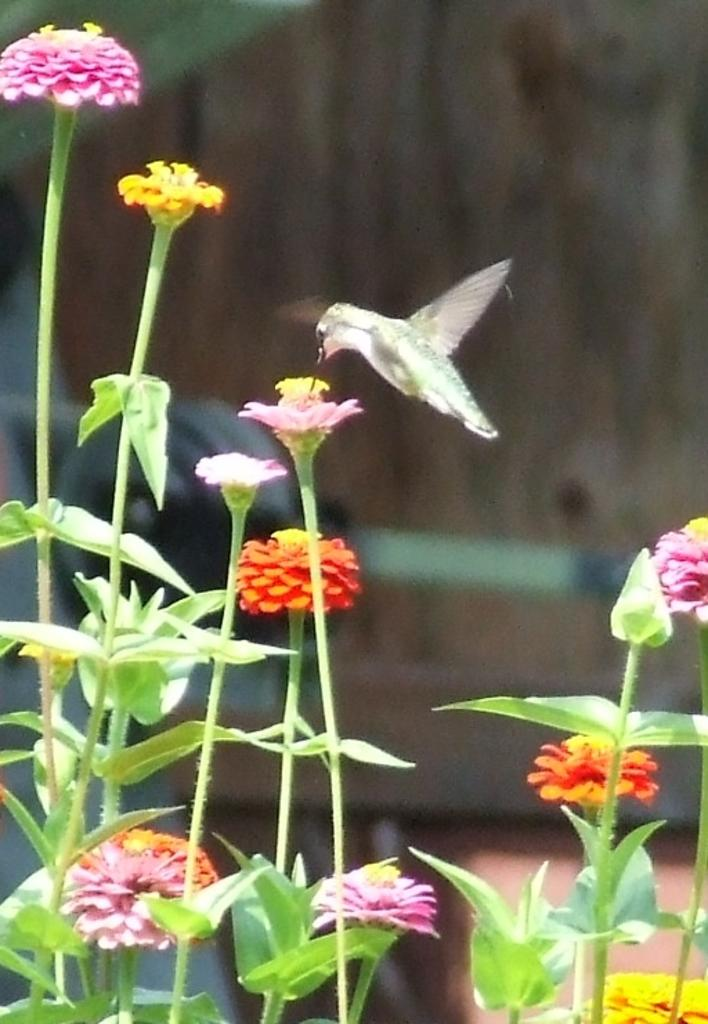What type of animal can be seen in the picture? There is a bird in the picture. Where is the bird located in relation to the flowers? The bird is near a flower in the image. How many flowers are visible in the image? There are multiple flowers in the image. Are the flowers attached to any plants? Yes, the flowers are on plants. What type of bone can be seen in the picture? There is no bone present in the image; it features a bird near a flower and multiple flowers on plants. 